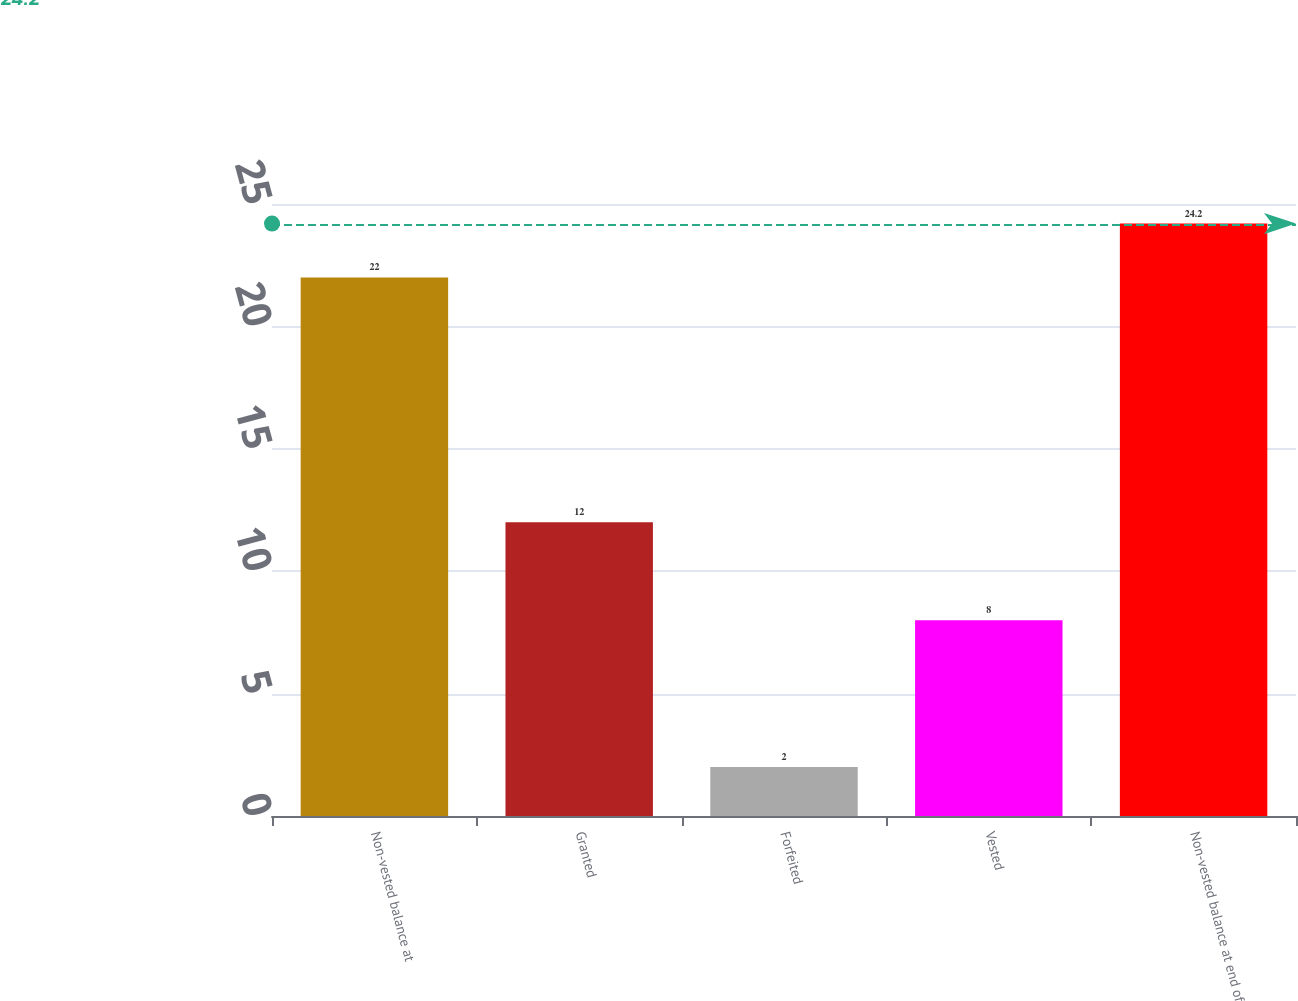<chart> <loc_0><loc_0><loc_500><loc_500><bar_chart><fcel>Non-vested balance at<fcel>Granted<fcel>Forfeited<fcel>Vested<fcel>Non-vested balance at end of<nl><fcel>22<fcel>12<fcel>2<fcel>8<fcel>24.2<nl></chart> 